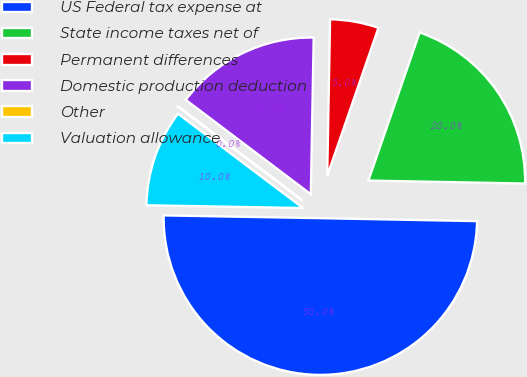Convert chart to OTSL. <chart><loc_0><loc_0><loc_500><loc_500><pie_chart><fcel>US Federal tax expense at<fcel>State income taxes net of<fcel>Permanent differences<fcel>Domestic production deduction<fcel>Other<fcel>Valuation allowance<nl><fcel>49.98%<fcel>20.0%<fcel>5.01%<fcel>15.0%<fcel>0.01%<fcel>10.0%<nl></chart> 